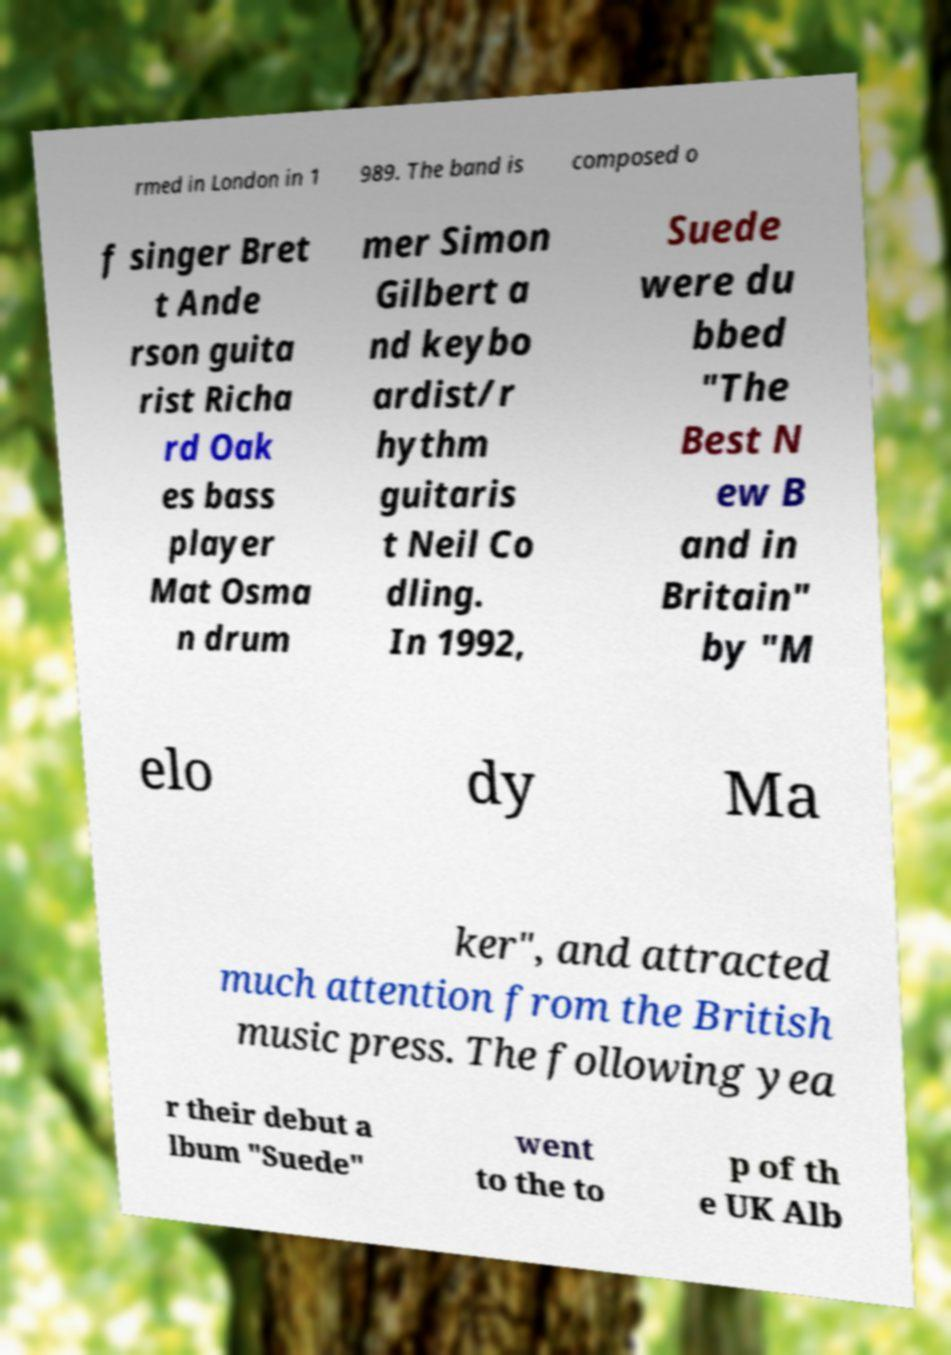Can you accurately transcribe the text from the provided image for me? rmed in London in 1 989. The band is composed o f singer Bret t Ande rson guita rist Richa rd Oak es bass player Mat Osma n drum mer Simon Gilbert a nd keybo ardist/r hythm guitaris t Neil Co dling. In 1992, Suede were du bbed "The Best N ew B and in Britain" by "M elo dy Ma ker", and attracted much attention from the British music press. The following yea r their debut a lbum "Suede" went to the to p of th e UK Alb 